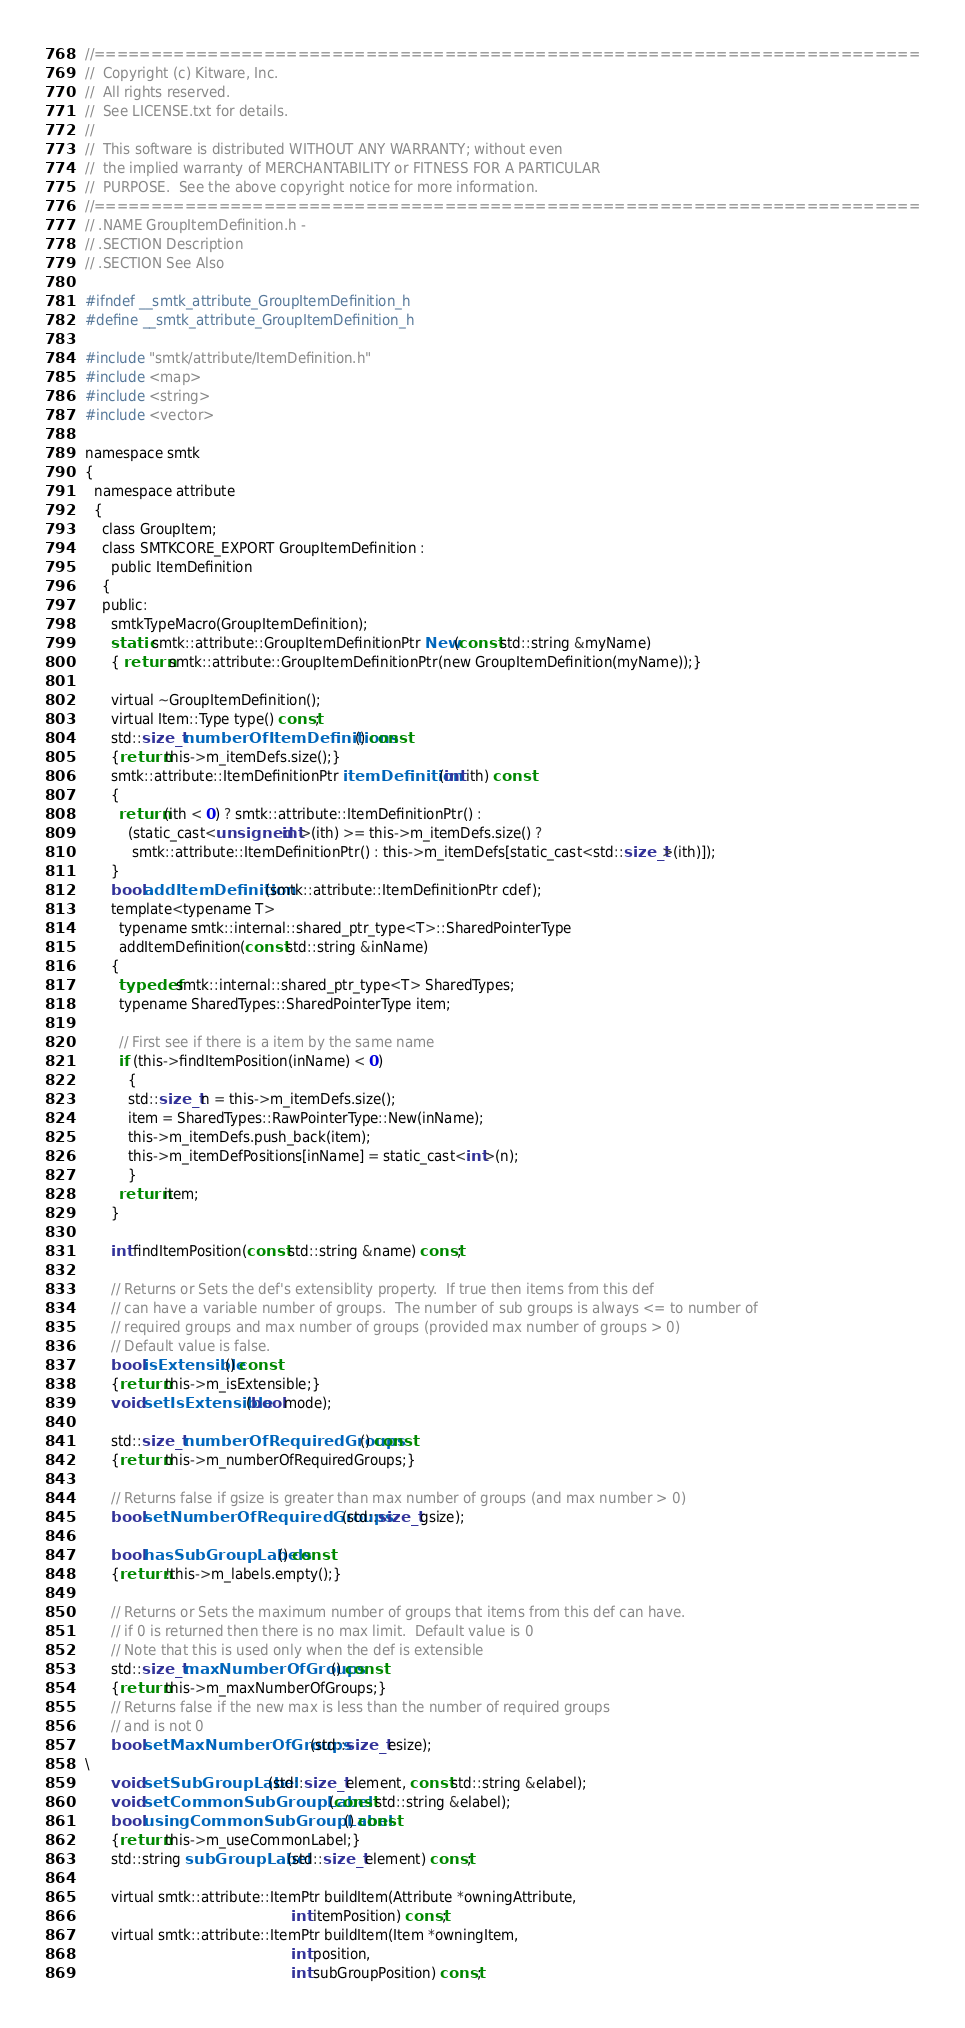<code> <loc_0><loc_0><loc_500><loc_500><_C_>//=========================================================================
//  Copyright (c) Kitware, Inc.
//  All rights reserved.
//  See LICENSE.txt for details.
//
//  This software is distributed WITHOUT ANY WARRANTY; without even
//  the implied warranty of MERCHANTABILITY or FITNESS FOR A PARTICULAR
//  PURPOSE.  See the above copyright notice for more information.
//=========================================================================
// .NAME GroupItemDefinition.h -
// .SECTION Description
// .SECTION See Also

#ifndef __smtk_attribute_GroupItemDefinition_h
#define __smtk_attribute_GroupItemDefinition_h

#include "smtk/attribute/ItemDefinition.h"
#include <map>
#include <string>
#include <vector>

namespace smtk
{
  namespace attribute
  {
    class GroupItem;
    class SMTKCORE_EXPORT GroupItemDefinition :
      public ItemDefinition
    {
    public:
      smtkTypeMacro(GroupItemDefinition);
      static smtk::attribute::GroupItemDefinitionPtr New(const std::string &myName)
      { return smtk::attribute::GroupItemDefinitionPtr(new GroupItemDefinition(myName));}

      virtual ~GroupItemDefinition();
      virtual Item::Type type() const;
      std::size_t numberOfItemDefinitions() const
      {return this->m_itemDefs.size();}
      smtk::attribute::ItemDefinitionPtr itemDefinition(int ith) const
      {
        return (ith < 0) ? smtk::attribute::ItemDefinitionPtr() :
          (static_cast<unsigned int>(ith) >= this->m_itemDefs.size() ?
           smtk::attribute::ItemDefinitionPtr() : this->m_itemDefs[static_cast<std::size_t>(ith)]);
      }
      bool addItemDefinition(smtk::attribute::ItemDefinitionPtr cdef);
      template<typename T>
        typename smtk::internal::shared_ptr_type<T>::SharedPointerType
        addItemDefinition(const std::string &inName)
      {
        typedef smtk::internal::shared_ptr_type<T> SharedTypes;
        typename SharedTypes::SharedPointerType item;

        // First see if there is a item by the same name
        if (this->findItemPosition(inName) < 0)
          {
          std::size_t n = this->m_itemDefs.size();
          item = SharedTypes::RawPointerType::New(inName);
          this->m_itemDefs.push_back(item);
          this->m_itemDefPositions[inName] = static_cast<int>(n);
          }
        return item;
      }

      int findItemPosition(const std::string &name) const;

      // Returns or Sets the def's extensiblity property.  If true then items from this def
      // can have a variable number of groups.  The number of sub groups is always <= to number of
      // required groups and max number of groups (provided max number of groups > 0)
      // Default value is false.
      bool isExtensible() const
      {return this->m_isExtensible;}
      void setIsExtensible(bool mode);

      std::size_t numberOfRequiredGroups() const
      {return this->m_numberOfRequiredGroups;}

      // Returns false if gsize is greater than max number of groups (and max number > 0)
      bool setNumberOfRequiredGroups(std::size_t gsize);

      bool hasSubGroupLabels() const
      {return !this->m_labels.empty();}

      // Returns or Sets the maximum number of groups that items from this def can have.
      // if 0 is returned then there is no max limit.  Default value is 0
      // Note that this is used only when the def is extensible
      std::size_t maxNumberOfGroups() const
      {return this->m_maxNumberOfGroups;}
      // Returns false if the new max is less than the number of required groups
      // and is not 0
      bool setMaxNumberOfGroups(std::size_t esize);
\
      void setSubGroupLabel(std::size_t element, const std::string &elabel);
      void setCommonSubGroupLabel(const std::string &elabel);
      bool usingCommonSubGroupLabel() const
      {return this->m_useCommonLabel;}
      std::string subGroupLabel(std::size_t element) const;

      virtual smtk::attribute::ItemPtr buildItem(Attribute *owningAttribute,
                                                int itemPosition) const;
      virtual smtk::attribute::ItemPtr buildItem(Item *owningItem,
                                                int position,
                                                int subGroupPosition) const;</code> 